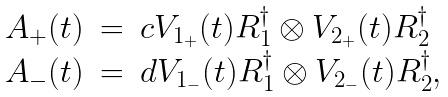<formula> <loc_0><loc_0><loc_500><loc_500>\begin{array} { l l l l } A _ { + } ( t ) & = & c V _ { 1 _ { + } } ( t ) R _ { 1 } ^ { \dagger } \otimes V _ { 2 _ { + } } ( t ) R _ { 2 } ^ { \dagger } \\ A _ { - } ( t ) & = & d V _ { 1 _ { - } } ( t ) R _ { 1 } ^ { \dagger } \otimes V _ { 2 _ { - } } ( t ) R _ { 2 } ^ { \dagger } , \, \end{array}</formula> 